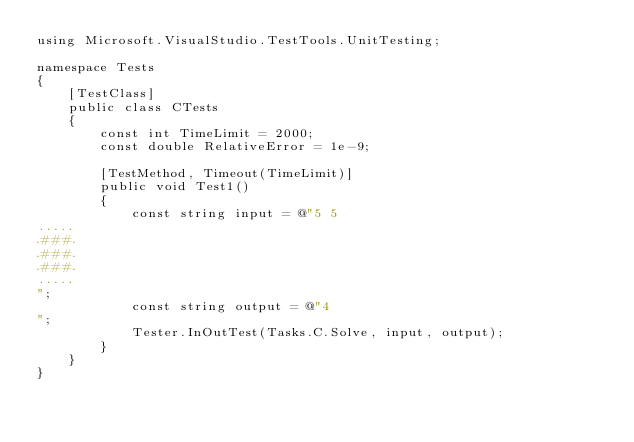<code> <loc_0><loc_0><loc_500><loc_500><_C#_>using Microsoft.VisualStudio.TestTools.UnitTesting;

namespace Tests
{
    [TestClass]
    public class CTests
    {
        const int TimeLimit = 2000;
        const double RelativeError = 1e-9;

        [TestMethod, Timeout(TimeLimit)]
        public void Test1()
        {
            const string input = @"5 5
.....
.###.
.###.
.###.
.....
";
            const string output = @"4
";
            Tester.InOutTest(Tasks.C.Solve, input, output);
        }
    }
}
</code> 